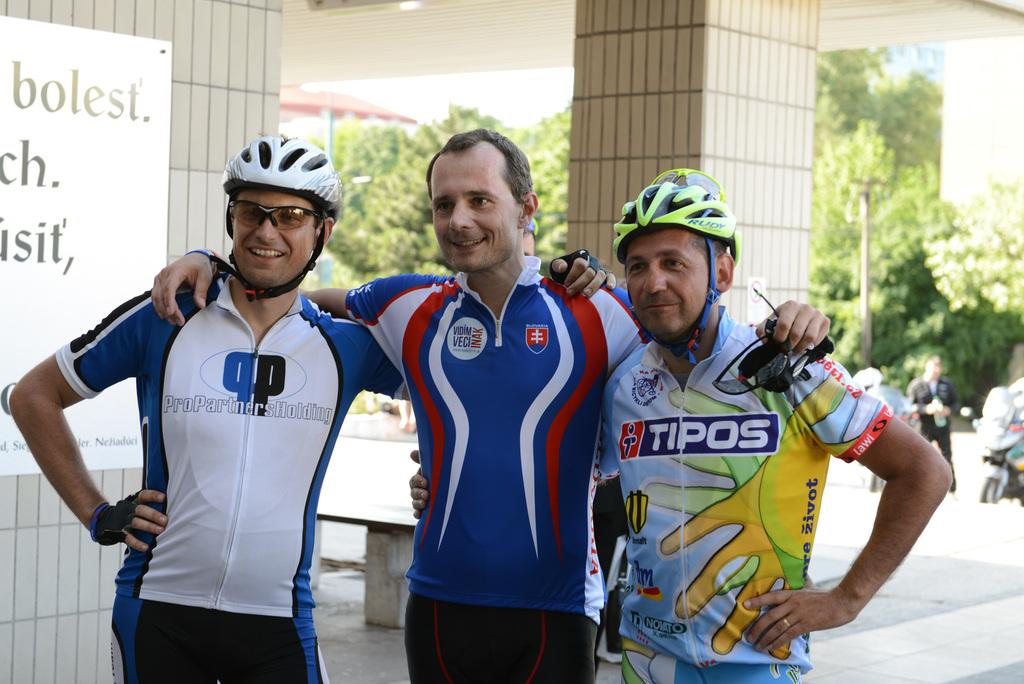<image>
Summarize the visual content of the image. The man with the yellow bike helmet has a shirt that says Tipos on it. 